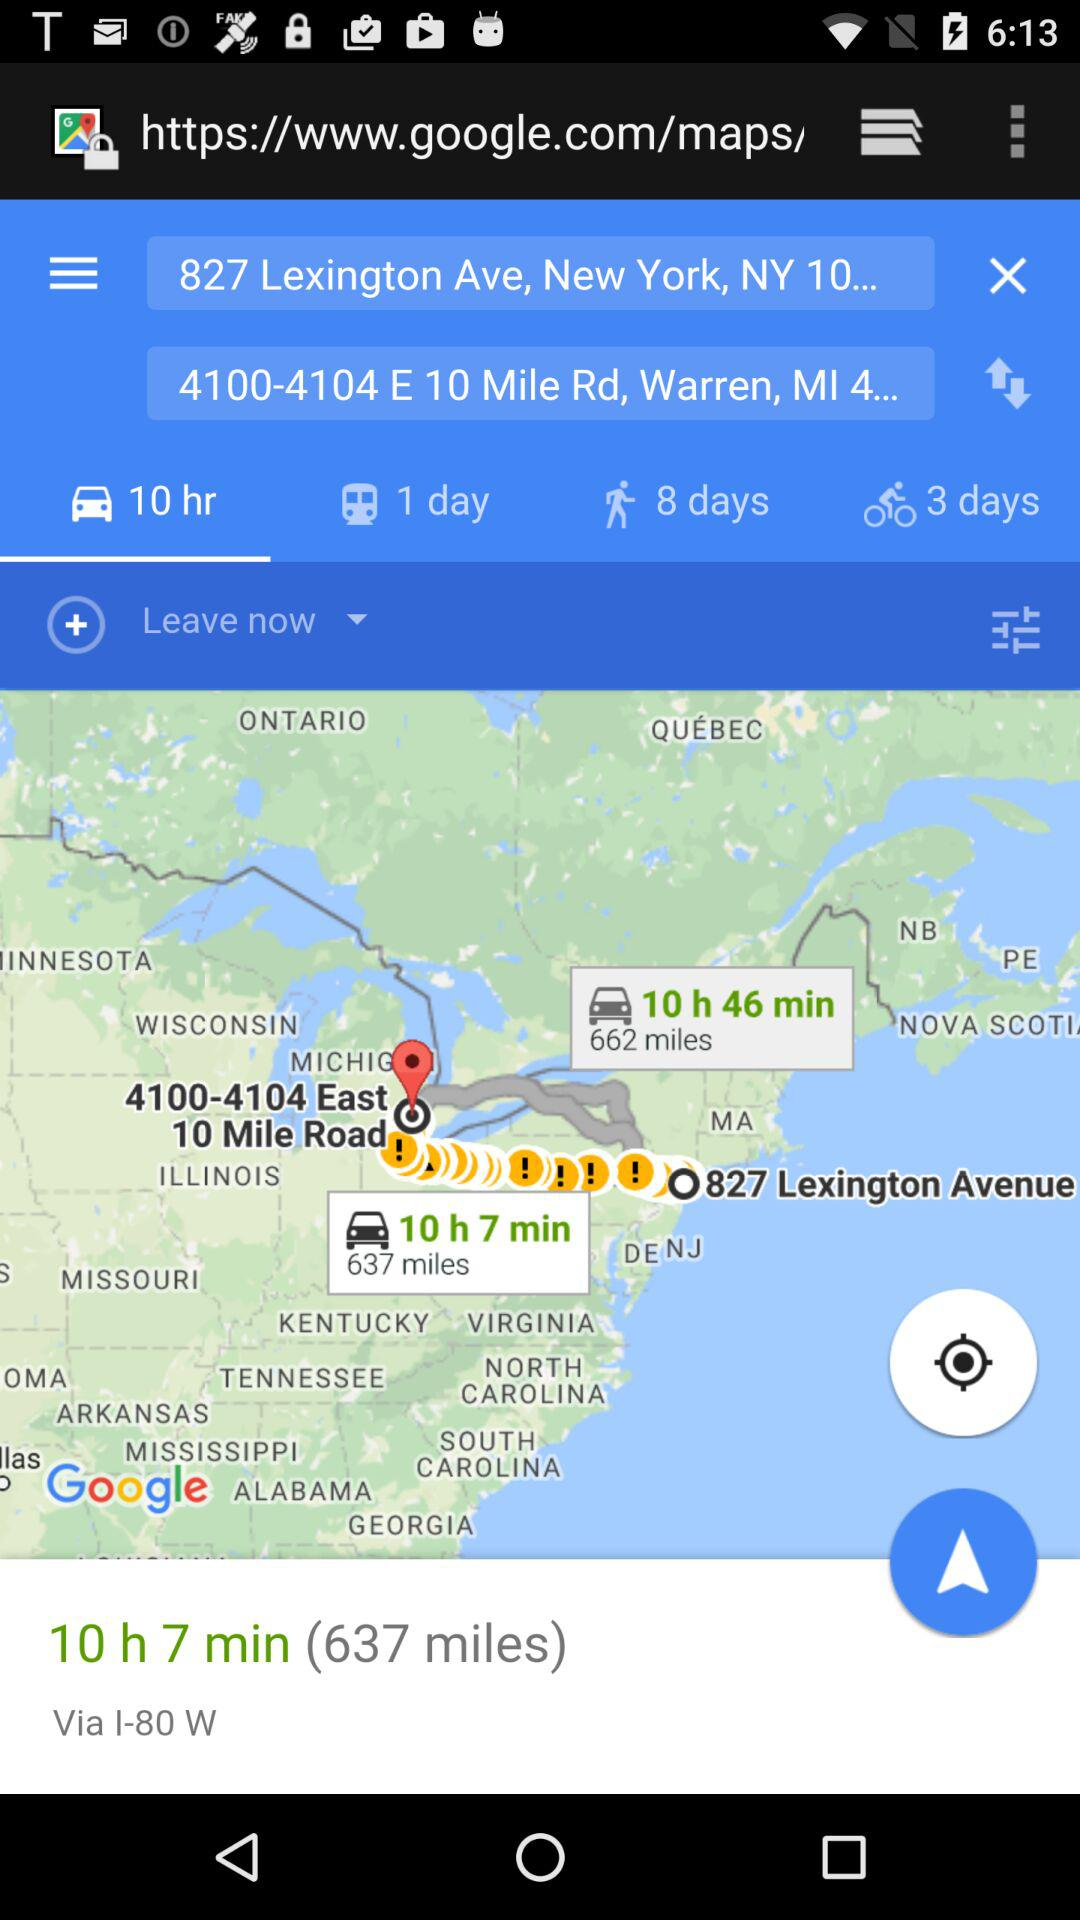How long will it take to walk from 827 Lexington Ave, New York, NY 10022 to 4100-4104 E 10 Mile Rd, Warren, MI 48093?
Answer the question using a single word or phrase. 8 days 